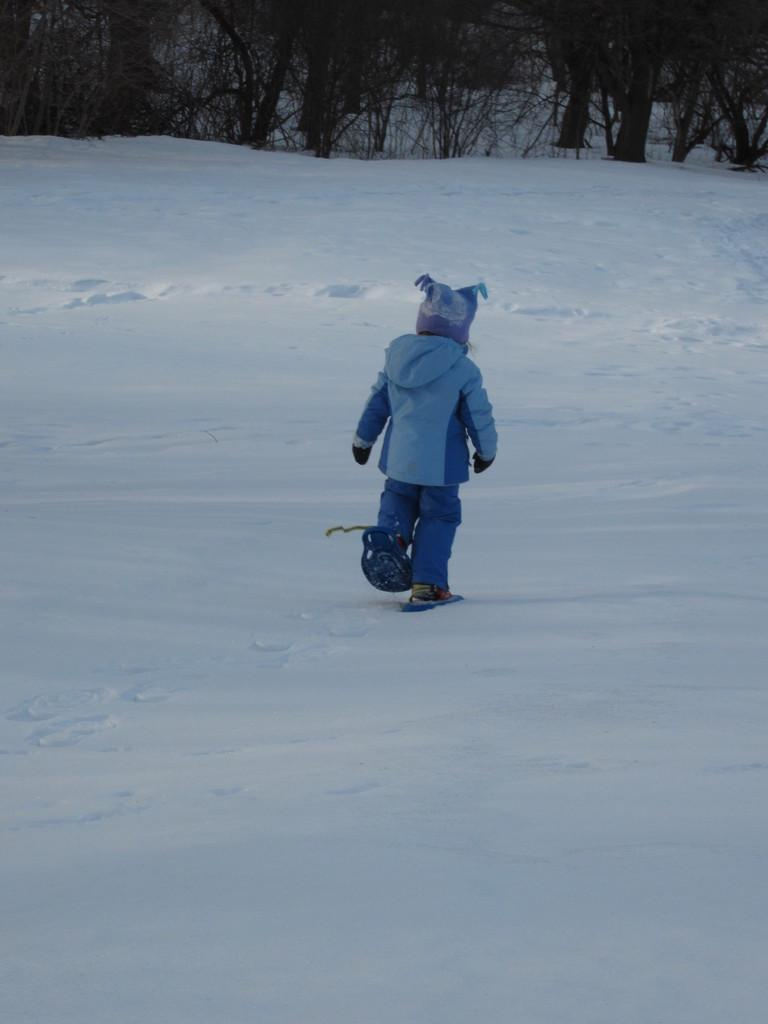What is the person in the image standing on? The person is standing on the snow. What is the person wearing in the image? The person is wearing a blue dress. What can be seen in the background of the image? There are trees in the background of the image. What type of clover can be seen growing near the person's feet in the image? There is no clover visible in the image; the person is standing on snow. Is there a porter nearby to assist the person in the image? There is no indication of a porter or any assistance needed in the image. 